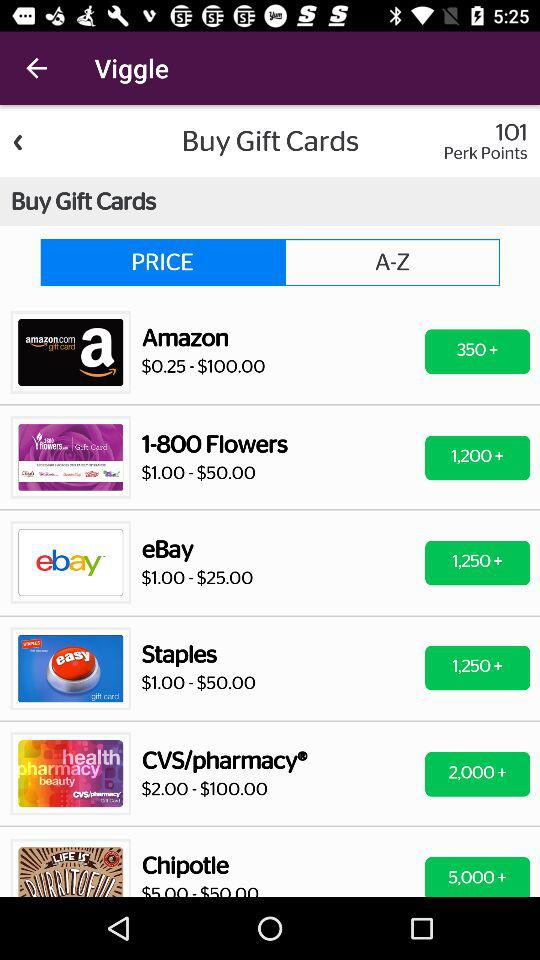What's the total perk points? The total perk points are 101. 